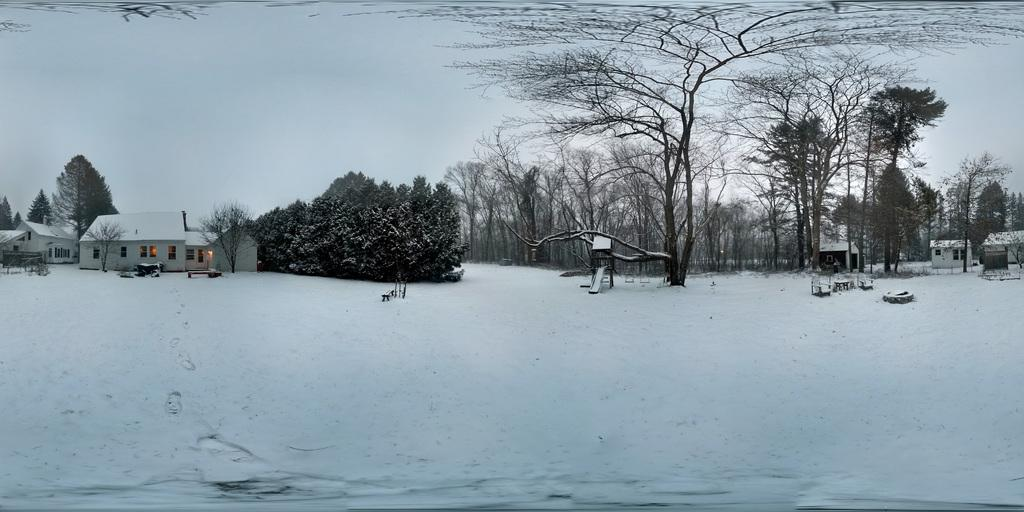What type of vegetation can be seen in the image? There are trees and plants in the image. What type of structures are present in the image? There are houses in the image. What type of playground equipment is visible in the image? There is a slider in the image. What architectural features can be seen in the image? There are windows and walls in the image. What is the weather like in the image? There is snow in the image, indicating a cold or wintery environment. What other objects can be seen in the image? There are other objects in the image, but their specific nature is not mentioned in the provided facts. What is visible in the background of the image? The sky is visible in the background of the image. Can you tell me how many nets are hanging from the trees in the image? There is no mention of nets in the image, so it is not possible to answer this question. What type of trouble is the person in the image experiencing? There is no person present in the image, so it is not possible to determine if they are experiencing any trouble. 